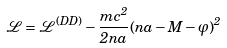Convert formula to latex. <formula><loc_0><loc_0><loc_500><loc_500>\mathcal { L } = \mathcal { L } ^ { ( D D ) } - \frac { m c ^ { 2 } } { 2 n a } ( n a - M - \varphi ) ^ { 2 }</formula> 